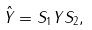Convert formula to latex. <formula><loc_0><loc_0><loc_500><loc_500>\hat { Y } = S _ { 1 } Y S _ { 2 } ,</formula> 